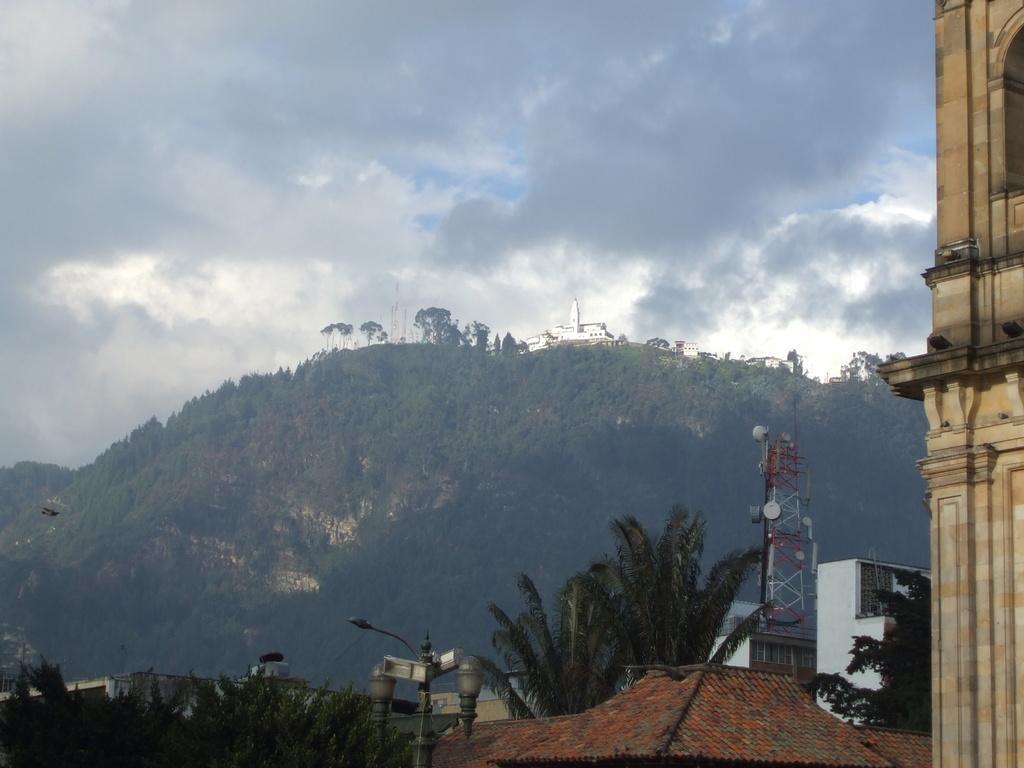Can you describe this image briefly? In the image we can see there are buildings, light pole, tower, trees, mountain and a cloudy sky. 